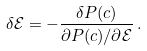Convert formula to latex. <formula><loc_0><loc_0><loc_500><loc_500>\delta \mathcal { E } = - \frac { \delta P ( c ) } { \partial P ( c ) / \partial \mathcal { E } } \, .</formula> 